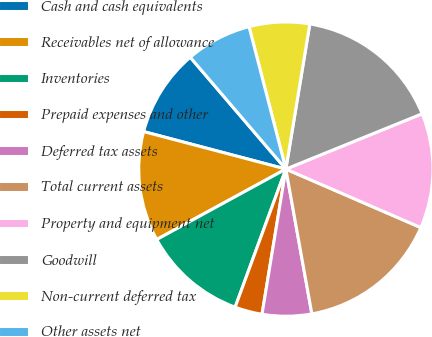<chart> <loc_0><loc_0><loc_500><loc_500><pie_chart><fcel>Cash and cash equivalents<fcel>Receivables net of allowance<fcel>Inventories<fcel>Prepaid expenses and other<fcel>Deferred tax assets<fcel>Total current assets<fcel>Property and equipment net<fcel>Goodwill<fcel>Non-current deferred tax<fcel>Other assets net<nl><fcel>9.64%<fcel>12.05%<fcel>11.45%<fcel>3.01%<fcel>5.42%<fcel>15.66%<fcel>12.65%<fcel>16.26%<fcel>6.63%<fcel>7.23%<nl></chart> 